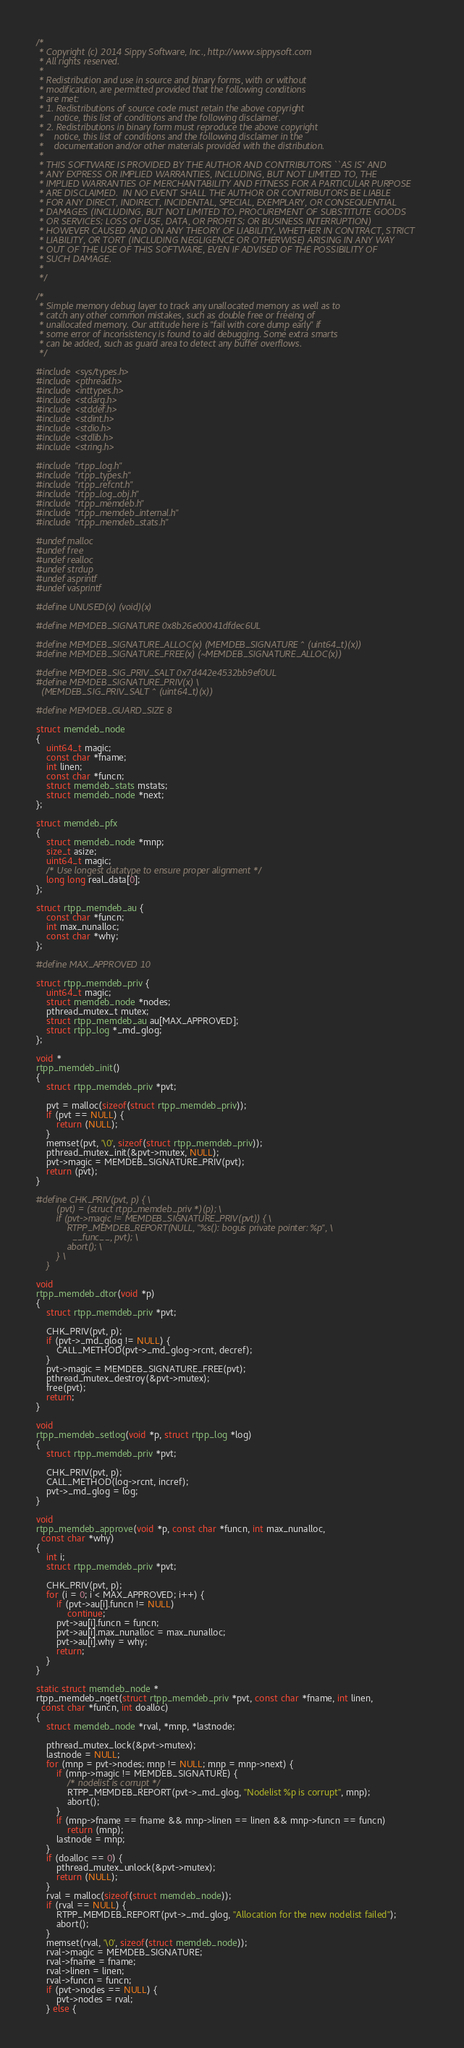Convert code to text. <code><loc_0><loc_0><loc_500><loc_500><_C_>/*
 * Copyright (c) 2014 Sippy Software, Inc., http://www.sippysoft.com
 * All rights reserved.
 *
 * Redistribution and use in source and binary forms, with or without
 * modification, are permitted provided that the following conditions
 * are met:
 * 1. Redistributions of source code must retain the above copyright
 *    notice, this list of conditions and the following disclaimer.
 * 2. Redistributions in binary form must reproduce the above copyright
 *    notice, this list of conditions and the following disclaimer in the
 *    documentation and/or other materials provided with the distribution.
 *
 * THIS SOFTWARE IS PROVIDED BY THE AUTHOR AND CONTRIBUTORS ``AS IS'' AND
 * ANY EXPRESS OR IMPLIED WARRANTIES, INCLUDING, BUT NOT LIMITED TO, THE
 * IMPLIED WARRANTIES OF MERCHANTABILITY AND FITNESS FOR A PARTICULAR PURPOSE
 * ARE DISCLAIMED.  IN NO EVENT SHALL THE AUTHOR OR CONTRIBUTORS BE LIABLE
 * FOR ANY DIRECT, INDIRECT, INCIDENTAL, SPECIAL, EXEMPLARY, OR CONSEQUENTIAL
 * DAMAGES (INCLUDING, BUT NOT LIMITED TO, PROCUREMENT OF SUBSTITUTE GOODS
 * OR SERVICES; LOSS OF USE, DATA, OR PROFITS; OR BUSINESS INTERRUPTION)
 * HOWEVER CAUSED AND ON ANY THEORY OF LIABILITY, WHETHER IN CONTRACT, STRICT
 * LIABILITY, OR TORT (INCLUDING NEGLIGENCE OR OTHERWISE) ARISING IN ANY WAY
 * OUT OF THE USE OF THIS SOFTWARE, EVEN IF ADVISED OF THE POSSIBILITY OF
 * SUCH DAMAGE.
 *
 */

/*
 * Simple memory debug layer to track any unallocated memory as well as to
 * catch any other common mistakes, such as double free or freeing of
 * unallocated memory. Our attitude here is "fail with core dump early" if
 * some error of inconsistency is found to aid debugging. Some extra smarts
 * can be added, such as guard area to detect any buffer overflows.
 */

#include <sys/types.h>
#include <pthread.h>
#include <inttypes.h>
#include <stdarg.h>
#include <stddef.h>
#include <stdint.h>
#include <stdio.h>
#include <stdlib.h>
#include <string.h>

#include "rtpp_log.h"
#include "rtpp_types.h"
#include "rtpp_refcnt.h"
#include "rtpp_log_obj.h"
#include "rtpp_memdeb.h"
#include "rtpp_memdeb_internal.h"
#include "rtpp_memdeb_stats.h"

#undef malloc
#undef free
#undef realloc
#undef strdup
#undef asprintf
#undef vasprintf

#define UNUSED(x) (void)(x)

#define MEMDEB_SIGNATURE 0x8b26e00041dfdec6UL

#define MEMDEB_SIGNATURE_ALLOC(x) (MEMDEB_SIGNATURE ^ (uint64_t)(x))
#define MEMDEB_SIGNATURE_FREE(x) (~MEMDEB_SIGNATURE_ALLOC(x))

#define MEMDEB_SIG_PRIV_SALT 0x7d442e4532bb9ef0UL
#define MEMDEB_SIGNATURE_PRIV(x) \
  (MEMDEB_SIG_PRIV_SALT ^ (uint64_t)(x))

#define MEMDEB_GUARD_SIZE 8

struct memdeb_node
{
    uint64_t magic;
    const char *fname;
    int linen;
    const char *funcn;
    struct memdeb_stats mstats;
    struct memdeb_node *next;
};

struct memdeb_pfx
{
    struct memdeb_node *mnp;
    size_t asize;
    uint64_t magic;
    /* Use longest datatype to ensure proper alignment */
    long long real_data[0];
};

struct rtpp_memdeb_au {
    const char *funcn;
    int max_nunalloc;
    const char *why;
};

#define MAX_APPROVED 10

struct rtpp_memdeb_priv {
    uint64_t magic;
    struct memdeb_node *nodes;
    pthread_mutex_t mutex;
    struct rtpp_memdeb_au au[MAX_APPROVED];
    struct rtpp_log *_md_glog;
};

void *
rtpp_memdeb_init()
{
    struct rtpp_memdeb_priv *pvt;

    pvt = malloc(sizeof(struct rtpp_memdeb_priv));
    if (pvt == NULL) {
        return (NULL);
    }
    memset(pvt, '\0', sizeof(struct rtpp_memdeb_priv));
    pthread_mutex_init(&pvt->mutex, NULL);
    pvt->magic = MEMDEB_SIGNATURE_PRIV(pvt);
    return (pvt);
}

#define CHK_PRIV(pvt, p) { \
        (pvt) = (struct rtpp_memdeb_priv *)(p); \
        if (pvt->magic != MEMDEB_SIGNATURE_PRIV(pvt)) { \
            RTPP_MEMDEB_REPORT(NULL, "%s(): bogus private pointer: %p", \
              __func__, pvt); \
            abort(); \
        } \
    }

void
rtpp_memdeb_dtor(void *p)
{
    struct rtpp_memdeb_priv *pvt;

    CHK_PRIV(pvt, p);
    if (pvt->_md_glog != NULL) {
        CALL_METHOD(pvt->_md_glog->rcnt, decref);
    }
    pvt->magic = MEMDEB_SIGNATURE_FREE(pvt);
    pthread_mutex_destroy(&pvt->mutex);
    free(pvt);
    return;
}

void
rtpp_memdeb_setlog(void *p, struct rtpp_log *log)
{
    struct rtpp_memdeb_priv *pvt;

    CHK_PRIV(pvt, p);
    CALL_METHOD(log->rcnt, incref);
    pvt->_md_glog = log;
}

void
rtpp_memdeb_approve(void *p, const char *funcn, int max_nunalloc,
  const char *why)
{
    int i;
    struct rtpp_memdeb_priv *pvt;

    CHK_PRIV(pvt, p);
    for (i = 0; i < MAX_APPROVED; i++) {
        if (pvt->au[i].funcn != NULL)
            continue;
        pvt->au[i].funcn = funcn;
        pvt->au[i].max_nunalloc = max_nunalloc;
        pvt->au[i].why = why;
        return;
    }
}

static struct memdeb_node *
rtpp_memdeb_nget(struct rtpp_memdeb_priv *pvt, const char *fname, int linen,
  const char *funcn, int doalloc)
{
    struct memdeb_node *rval, *mnp, *lastnode;

    pthread_mutex_lock(&pvt->mutex);
    lastnode = NULL;
    for (mnp = pvt->nodes; mnp != NULL; mnp = mnp->next) {
        if (mnp->magic != MEMDEB_SIGNATURE) {
            /* nodelist is corrupt */
            RTPP_MEMDEB_REPORT(pvt->_md_glog, "Nodelist %p is corrupt", mnp);
            abort();
        }
        if (mnp->fname == fname && mnp->linen == linen && mnp->funcn == funcn)
            return (mnp);
        lastnode = mnp;
    }
    if (doalloc == 0) {
        pthread_mutex_unlock(&pvt->mutex);
        return (NULL);
    }
    rval = malloc(sizeof(struct memdeb_node));
    if (rval == NULL) {
        RTPP_MEMDEB_REPORT(pvt->_md_glog, "Allocation for the new nodelist failed");
        abort();
    }
    memset(rval, '\0', sizeof(struct memdeb_node));
    rval->magic = MEMDEB_SIGNATURE;
    rval->fname = fname;
    rval->linen = linen;
    rval->funcn = funcn;
    if (pvt->nodes == NULL) {
        pvt->nodes = rval;
    } else {</code> 